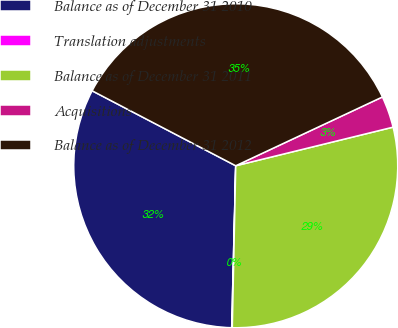Convert chart to OTSL. <chart><loc_0><loc_0><loc_500><loc_500><pie_chart><fcel>Balance as of December 31 2010<fcel>Translation adjustments<fcel>Balance as of December 31 2011<fcel>Acquisitions<fcel>Balance as of December 31 2012<nl><fcel>32.26%<fcel>0.06%<fcel>29.17%<fcel>3.15%<fcel>35.36%<nl></chart> 